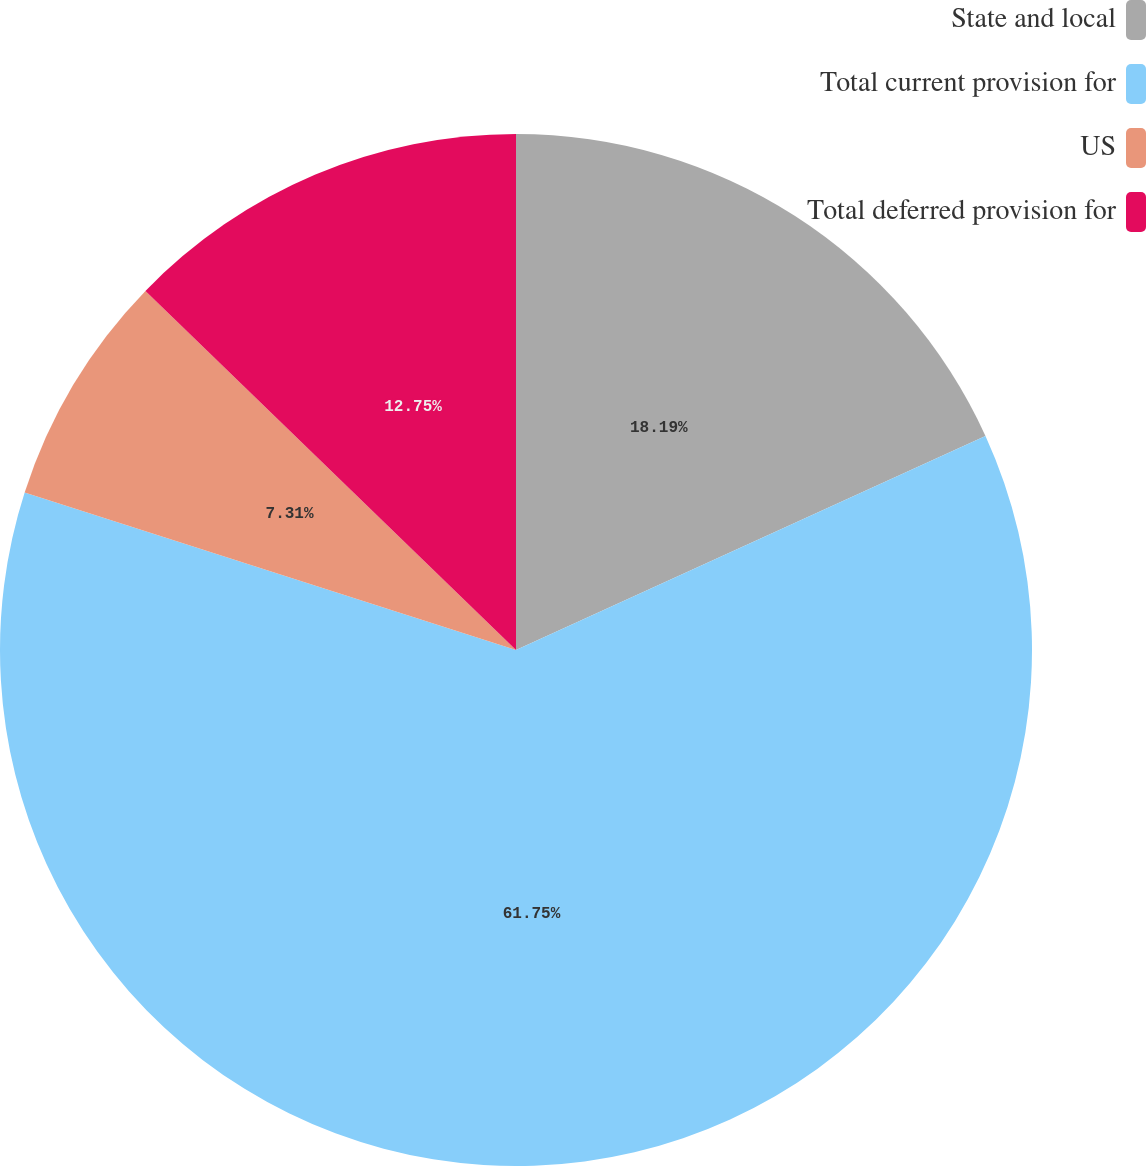<chart> <loc_0><loc_0><loc_500><loc_500><pie_chart><fcel>State and local<fcel>Total current provision for<fcel>US<fcel>Total deferred provision for<nl><fcel>18.19%<fcel>61.75%<fcel>7.31%<fcel>12.75%<nl></chart> 